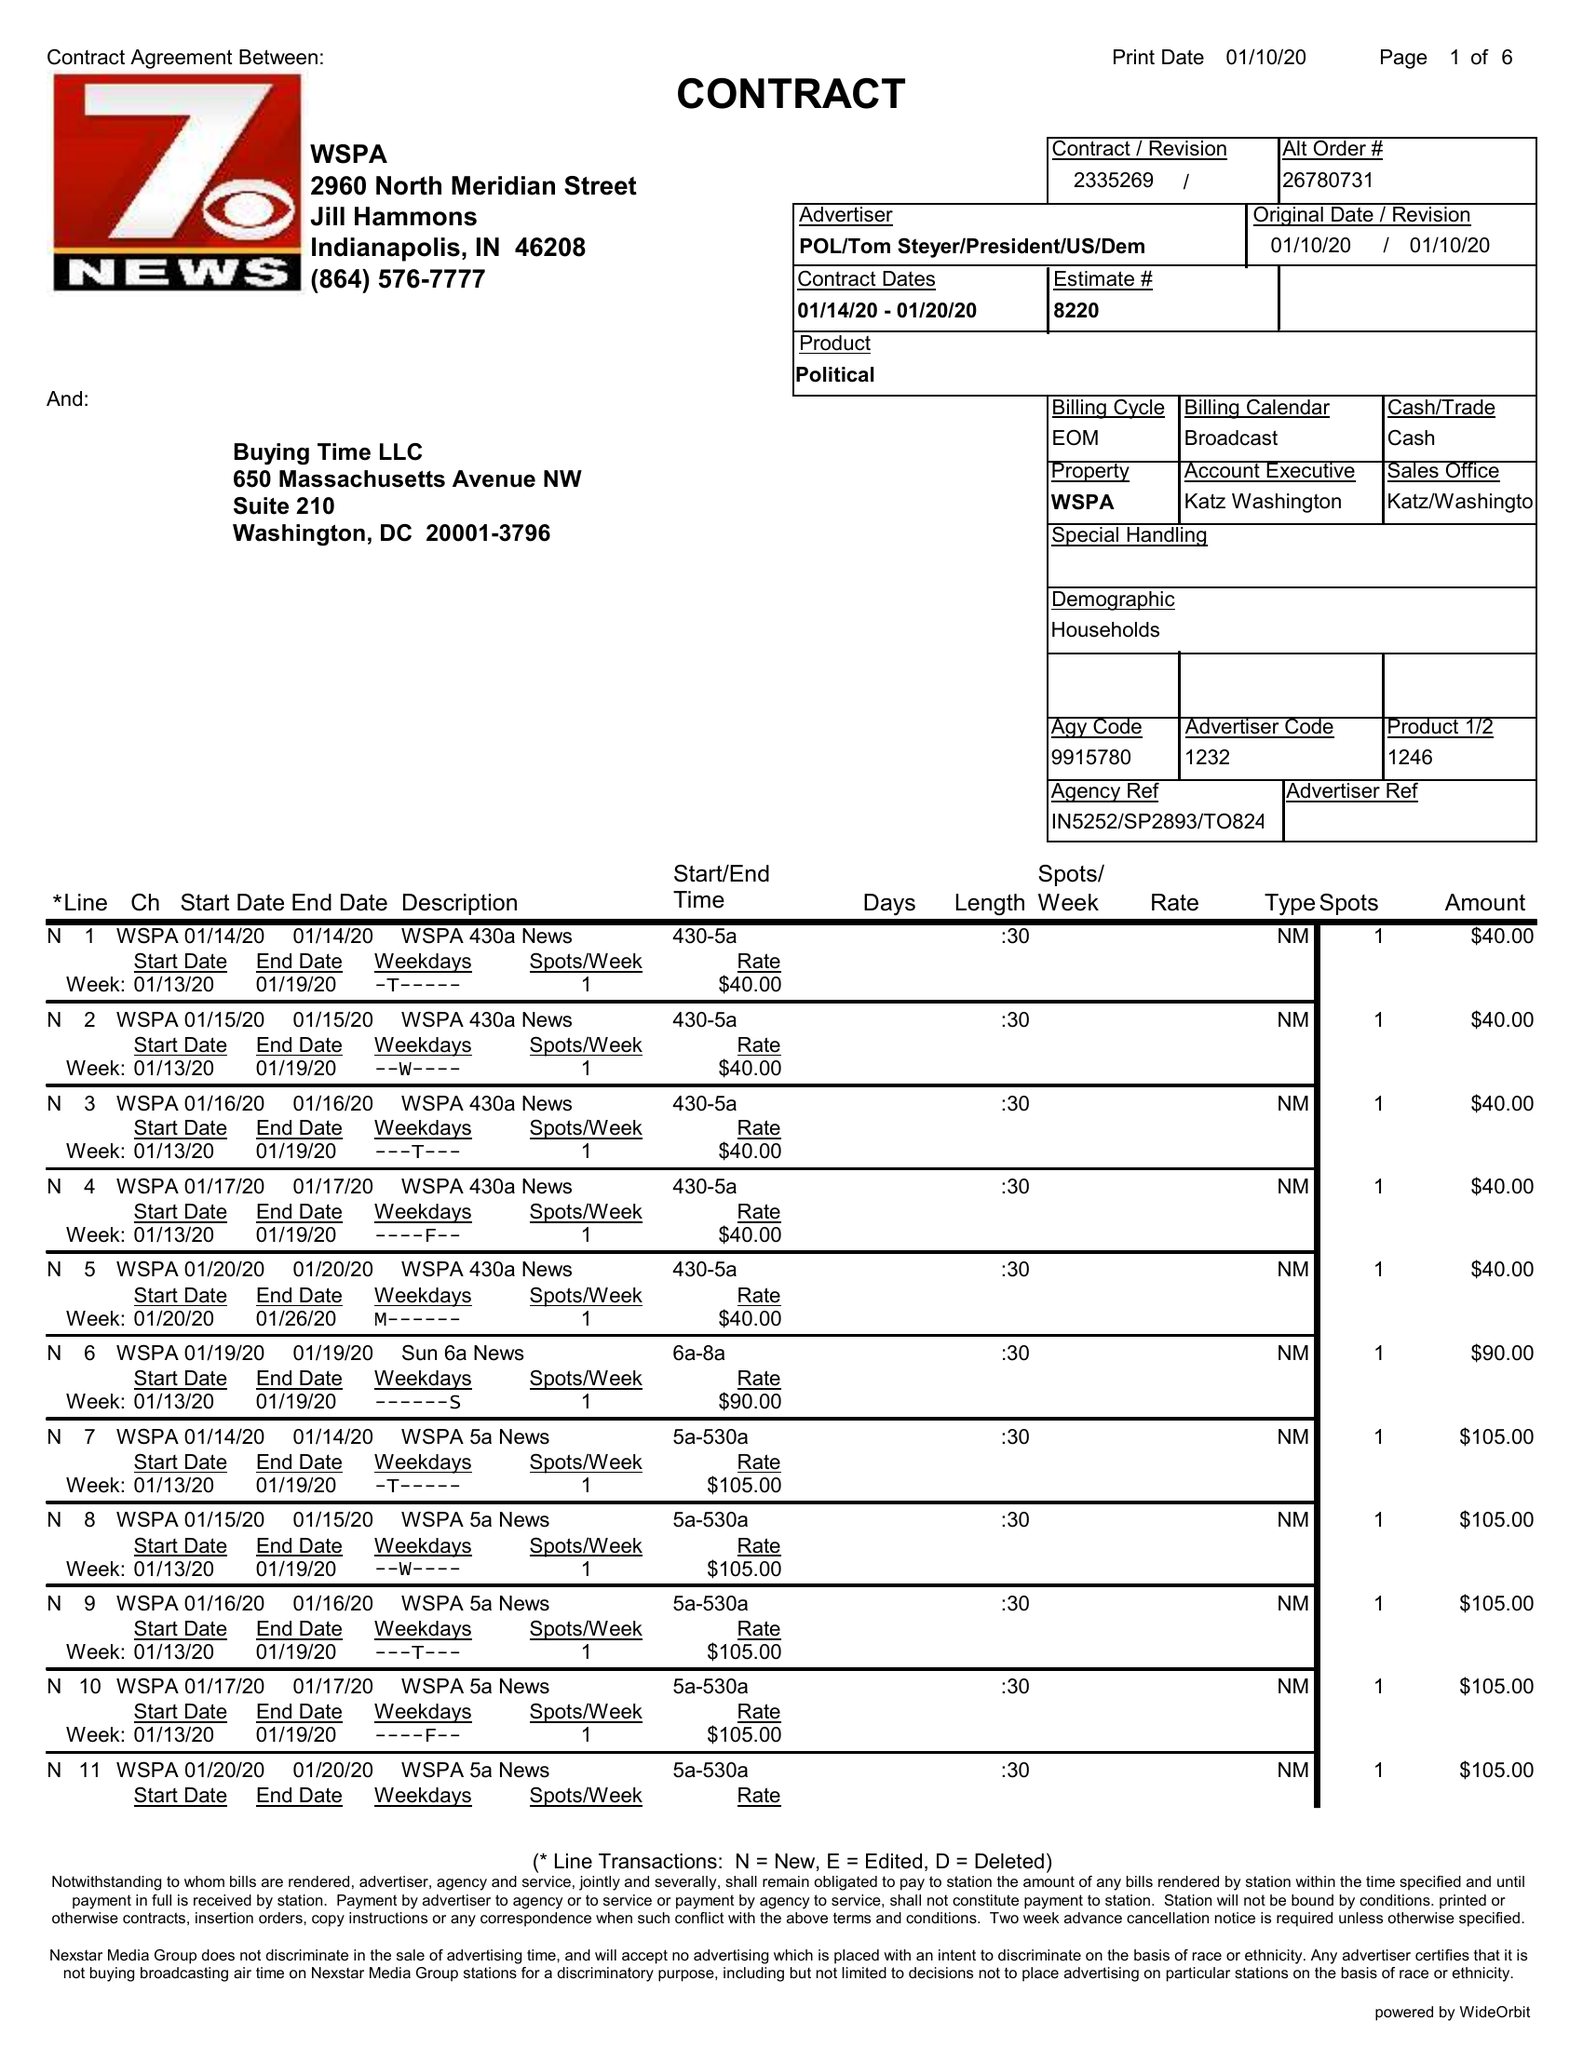What is the value for the contract_num?
Answer the question using a single word or phrase. 2335269 